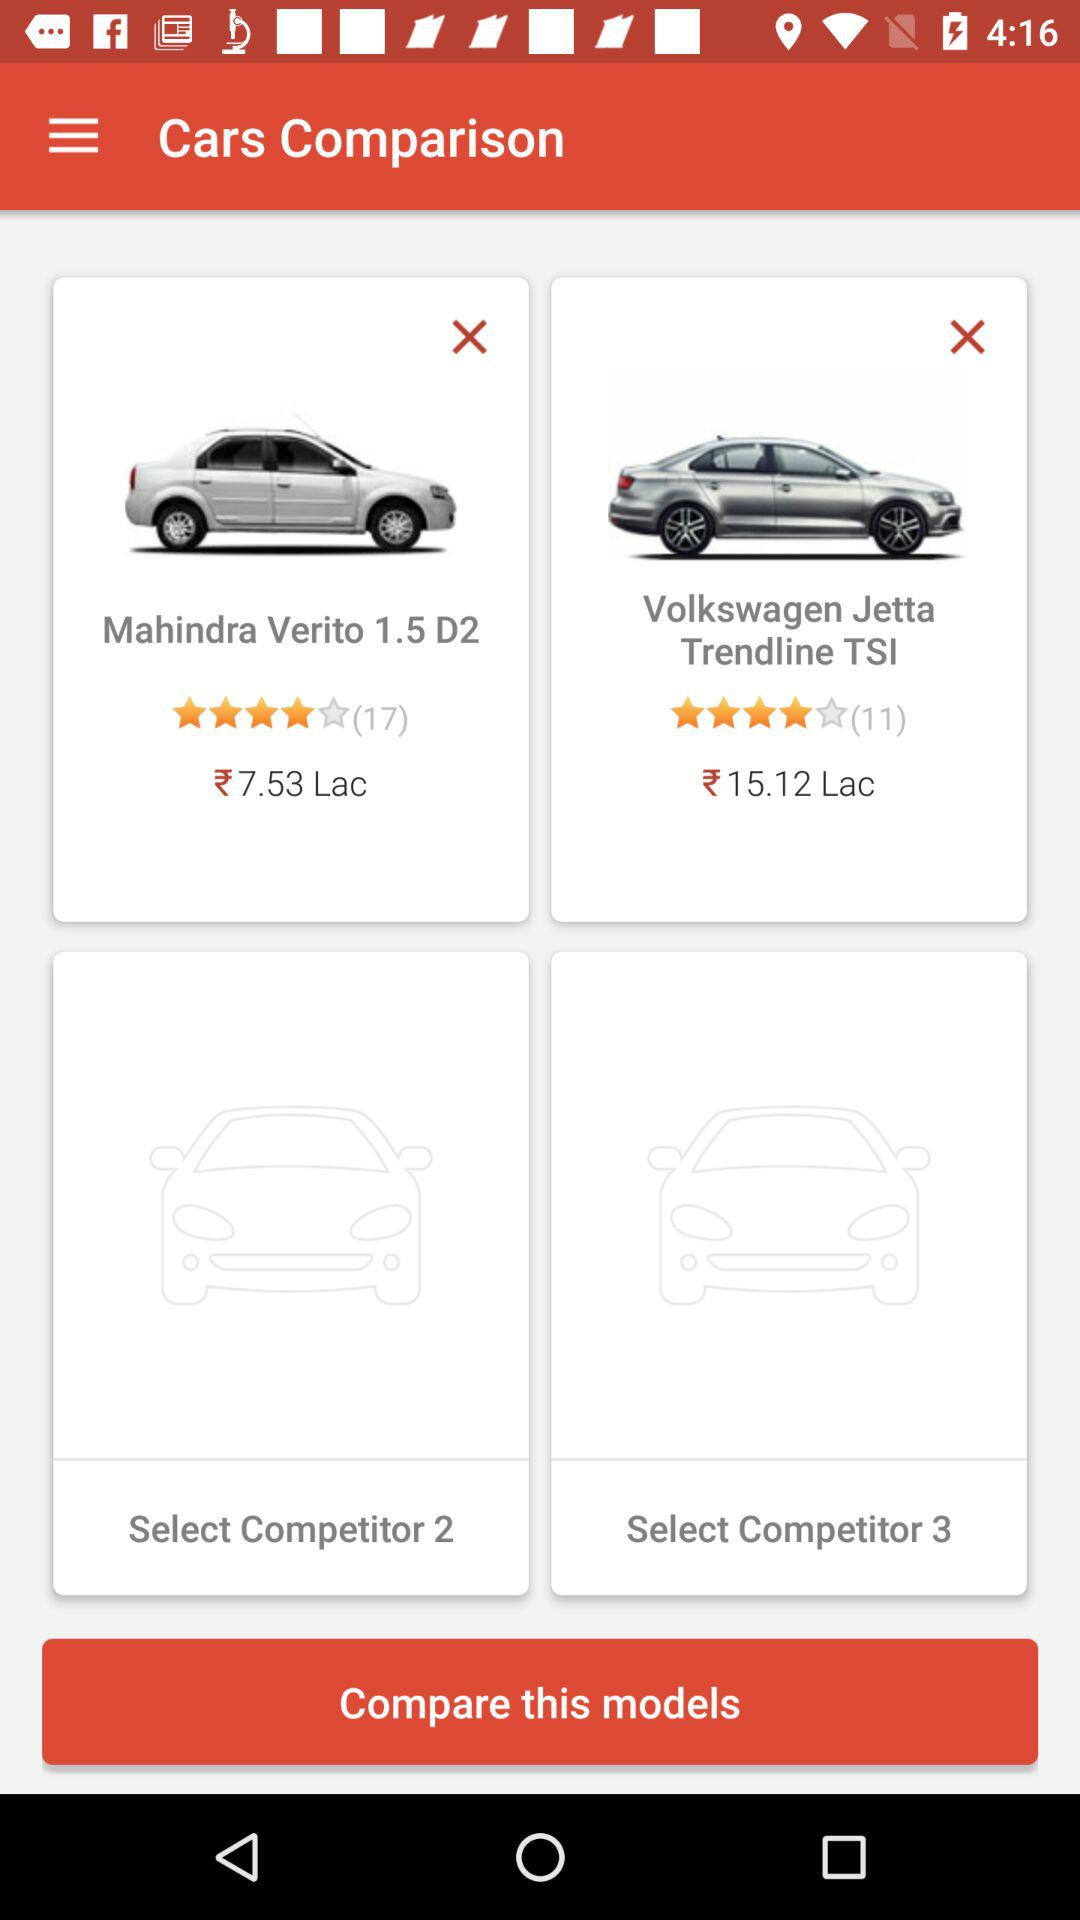What is the price of the "Volkswagen Jetta Trendline TSI"? The price is ₹15.12 lakh. 